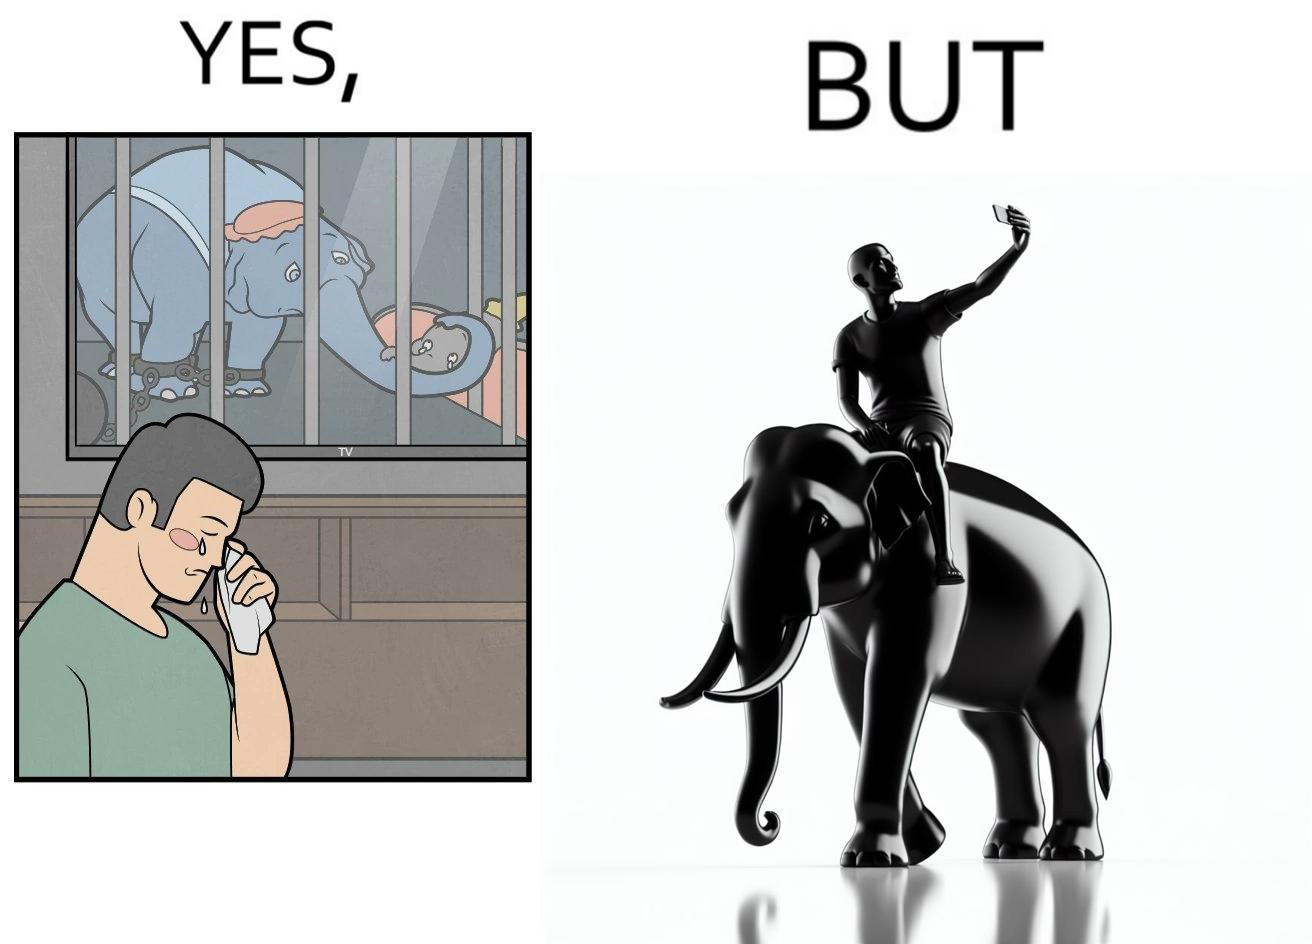Would you classify this image as satirical? Yes, this image is satirical. 